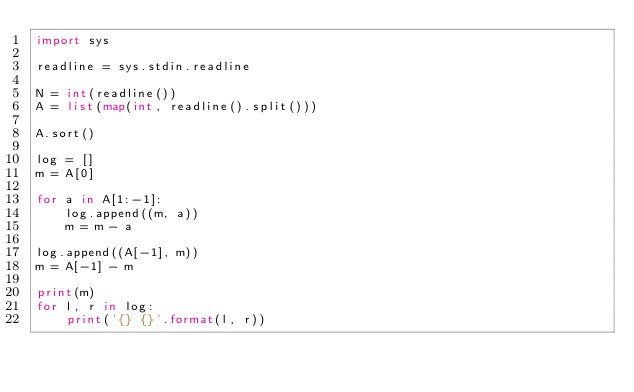<code> <loc_0><loc_0><loc_500><loc_500><_Python_>import sys

readline = sys.stdin.readline

N = int(readline())
A = list(map(int, readline().split()))

A.sort()

log = []
m = A[0]

for a in A[1:-1]:
    log.append((m, a))
    m = m - a

log.append((A[-1], m))
m = A[-1] - m

print(m)
for l, r in log:
    print('{} {}'.format(l, r))
    </code> 